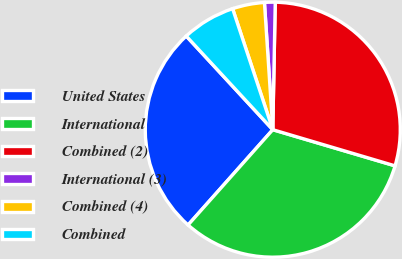Convert chart. <chart><loc_0><loc_0><loc_500><loc_500><pie_chart><fcel>United States<fcel>International<fcel>Combined (2)<fcel>International (3)<fcel>Combined (4)<fcel>Combined<nl><fcel>26.56%<fcel>31.99%<fcel>29.27%<fcel>1.35%<fcel>4.06%<fcel>6.77%<nl></chart> 